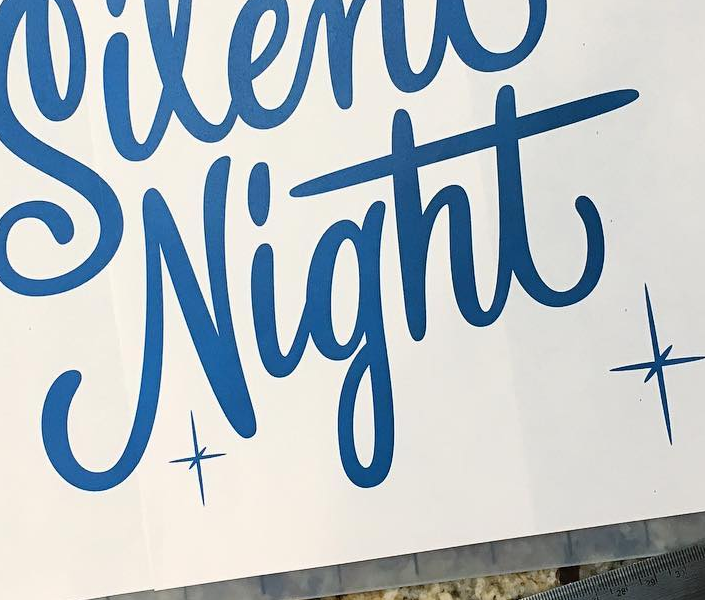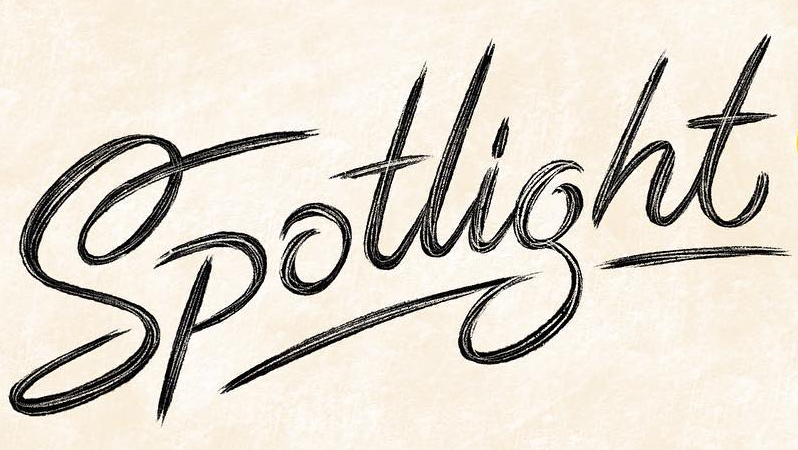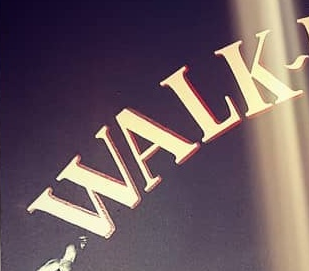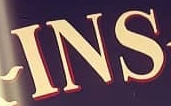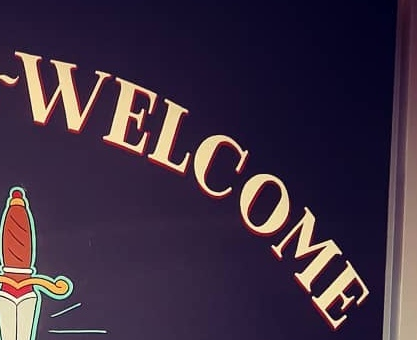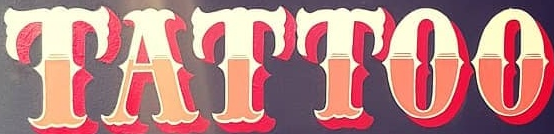Read the text content from these images in order, separated by a semicolon. Night; Spotlight; WALK; INS; WELCOME; TATTOO 